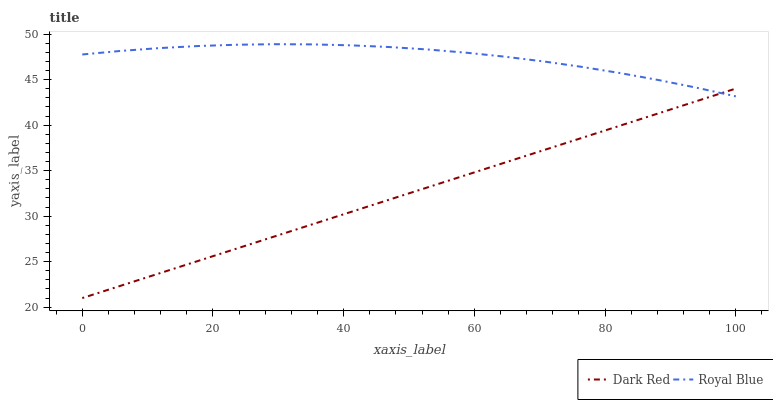Does Royal Blue have the minimum area under the curve?
Answer yes or no. No. Is Royal Blue the smoothest?
Answer yes or no. No. Does Royal Blue have the lowest value?
Answer yes or no. No. 